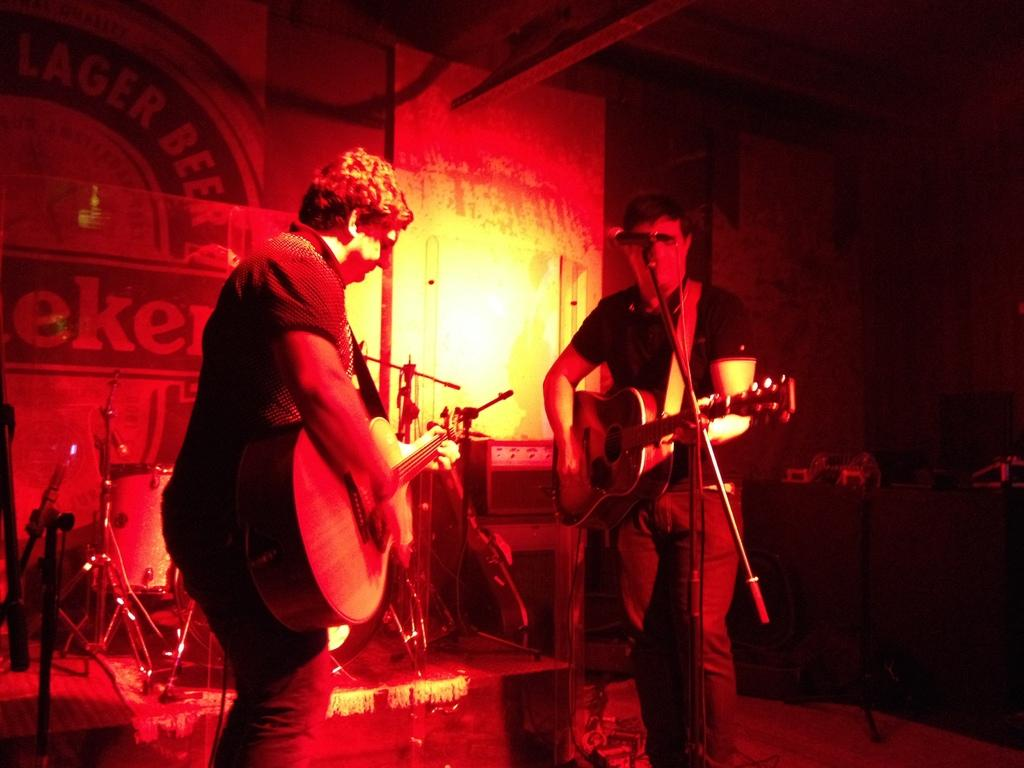How many people are in the image? There are two people in the image. Where are the two people located? The two people are standing on a stage. What are the two people doing on the stage? The two people are playing musical instruments. What type of curtain can be seen behind the two people on the stage? There is no curtain visible behind the two people on the stage in the image. How many rabbits are present on the stage with the two people? There are no rabbits present on the stage with the two people in the image. 